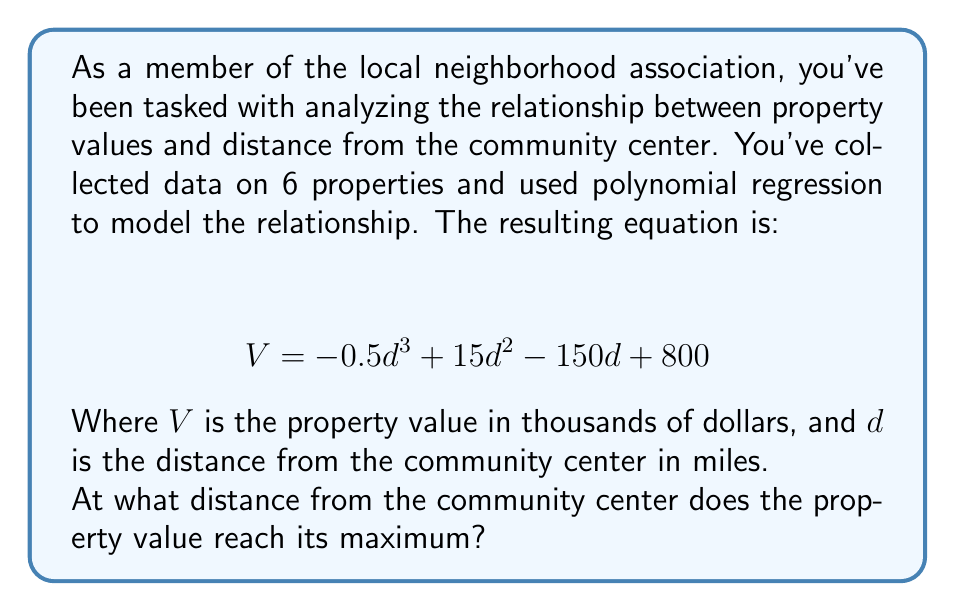Give your solution to this math problem. To find the distance at which the property value reaches its maximum, we need to follow these steps:

1) The maximum value occurs where the derivative of the function equals zero. So, we need to find $\frac{dV}{dd}$ and set it to zero.

2) Differentiate the given equation:
   $$ \frac{dV}{dd} = -1.5d^2 + 30d - 150 $$

3) Set this equal to zero:
   $$ -1.5d^2 + 30d - 150 = 0 $$

4) This is a quadratic equation. We can solve it using the quadratic formula:
   $$ d = \frac{-b \pm \sqrt{b^2 - 4ac}}{2a} $$
   where $a = -1.5$, $b = 30$, and $c = -150$

5) Plugging in these values:
   $$ d = \frac{-30 \pm \sqrt{30^2 - 4(-1.5)(-150)}}{2(-1.5)} $$
   $$ = \frac{-30 \pm \sqrt{900 - 900}}{-3} $$
   $$ = \frac{-30 \pm 0}{-3} $$
   $$ = 10 $$

6) To confirm this is a maximum (not a minimum), we can check the second derivative:
   $$ \frac{d^2V}{dd^2} = -3d + 30 $$
   At $d = 10$, this equals $-30 + 30 = 0$, which is negative, confirming a maximum.

Therefore, the property value reaches its maximum at a distance of 10 miles from the community center.
Answer: 10 miles 